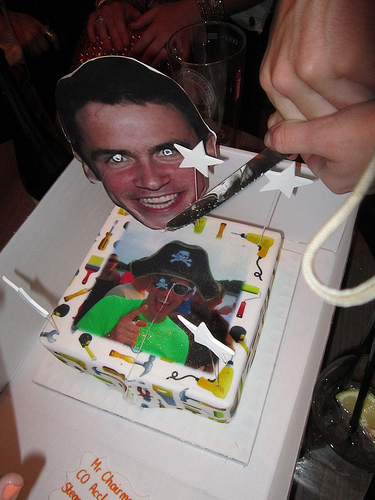Please provide a short description for this region: [0.23, 0.11, 0.56, 0.46]. Within these coordinates, there appears to be a cutout displaying a person's face, marked with a broad, cheerful smile, likely contributing to the overall jovial theme of the gathering. 